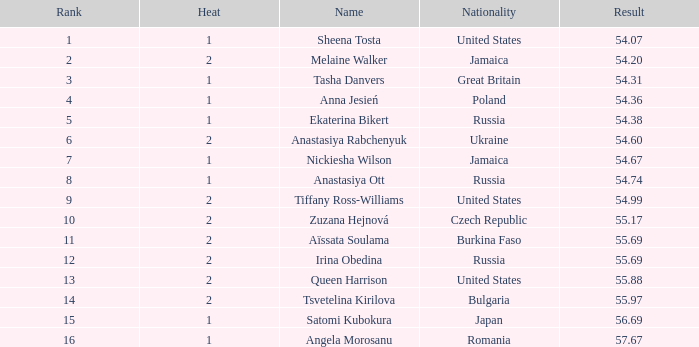97? None. 